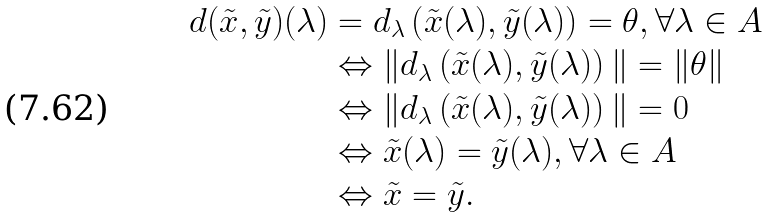<formula> <loc_0><loc_0><loc_500><loc_500>d ( \tilde { x } , \tilde { y } ) ( \lambda ) & = d _ { \lambda } \left ( \tilde { x } ( \lambda ) , \tilde { y } ( \lambda ) \right ) = \theta , \forall \lambda \in A \\ & \Leftrightarrow \| d _ { \lambda } \left ( \tilde { x } ( \lambda ) , \tilde { y } ( \lambda ) \right ) \| = \| \theta \| \\ & \Leftrightarrow \| d _ { \lambda } \left ( \tilde { x } ( \lambda ) , \tilde { y } ( \lambda ) \right ) \| = 0 \\ & \Leftrightarrow \tilde { x } ( \lambda ) = \tilde { y } ( \lambda ) , \forall \lambda \in A \\ & \Leftrightarrow \tilde { x } = \tilde { y } .</formula> 